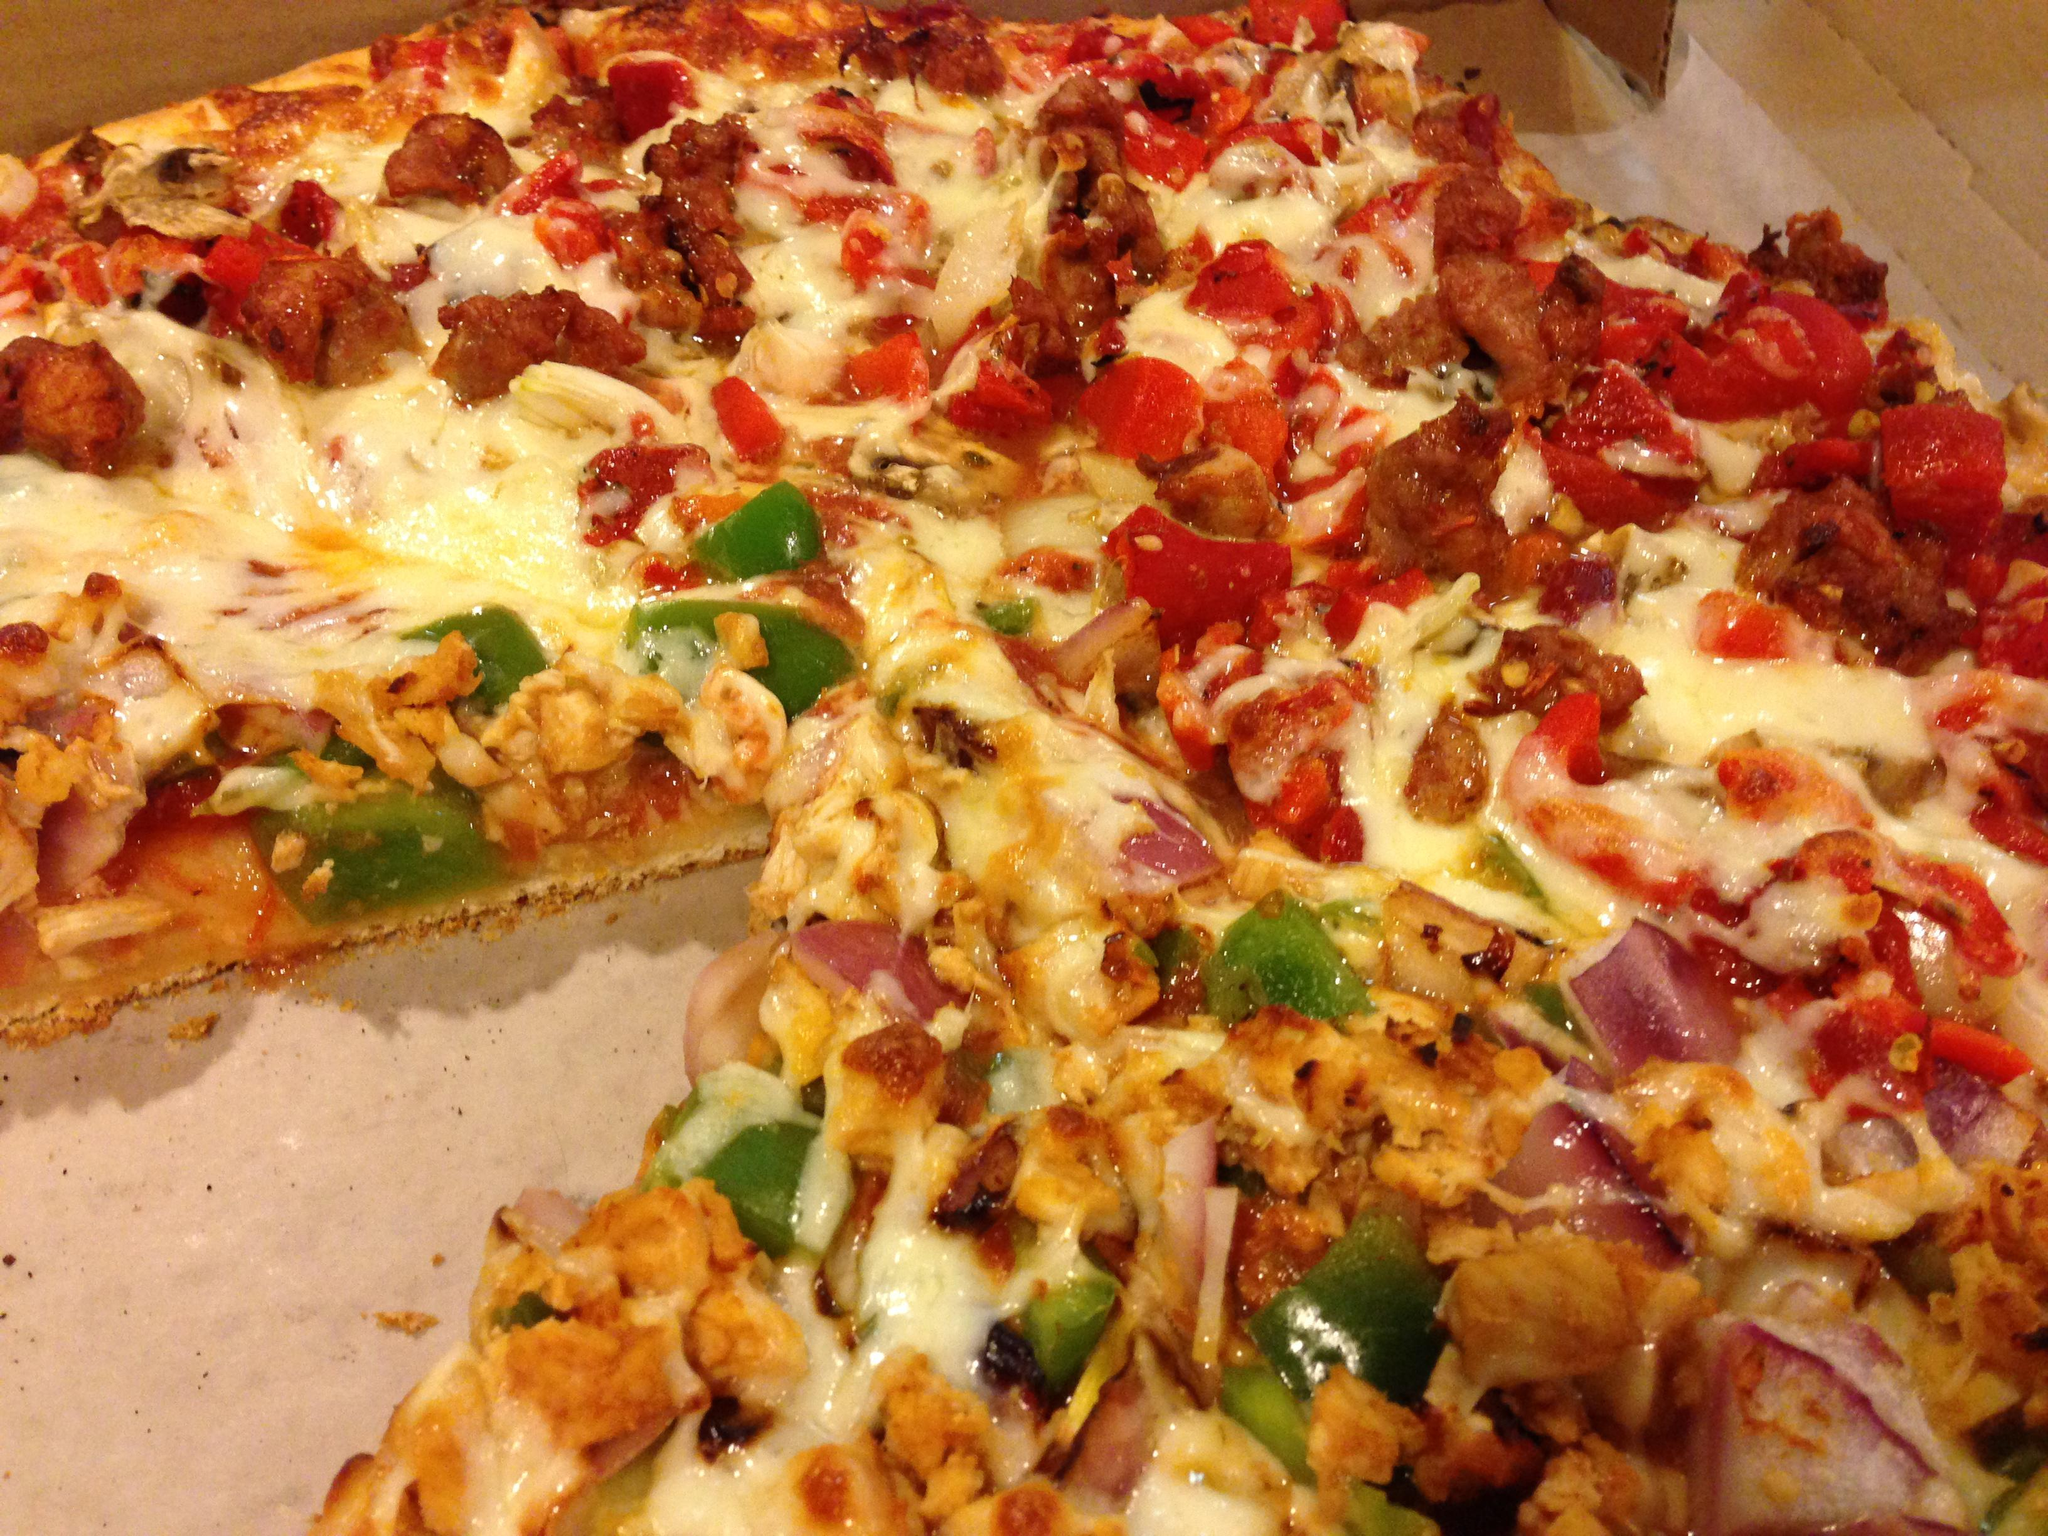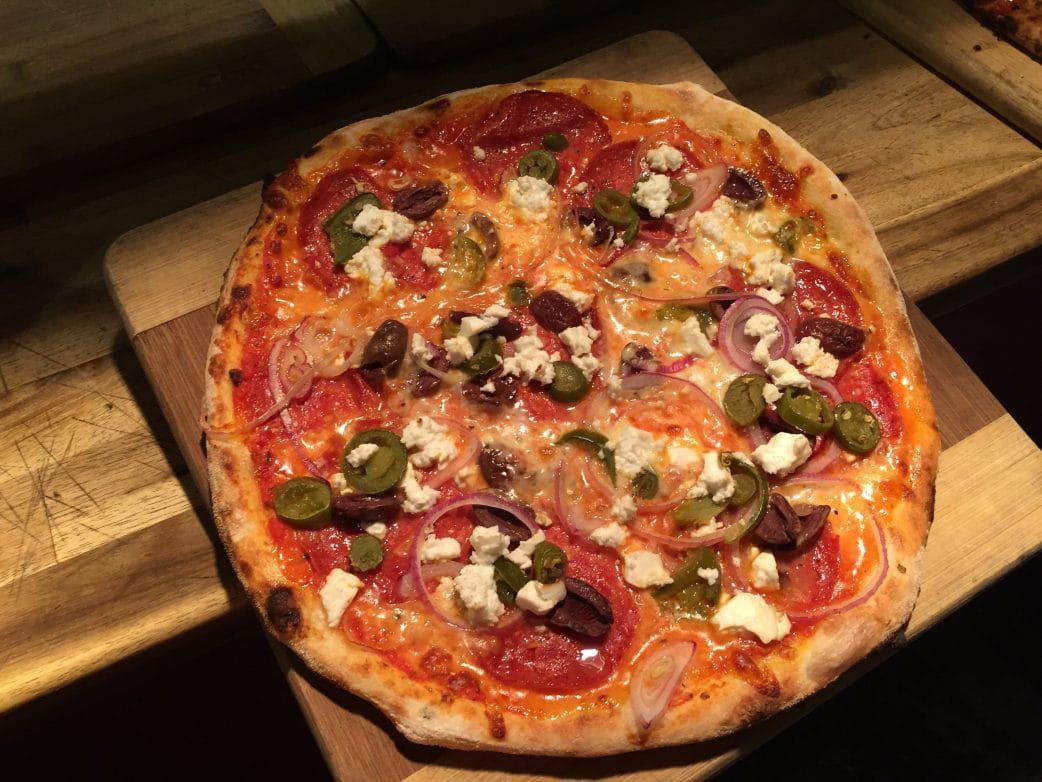The first image is the image on the left, the second image is the image on the right. Analyze the images presented: Is the assertion "There are two pizza and none of them are in a cardboard box." valid? Answer yes or no. No. The first image is the image on the left, the second image is the image on the right. Considering the images on both sides, is "A piece of pizza is missing." valid? Answer yes or no. Yes. 